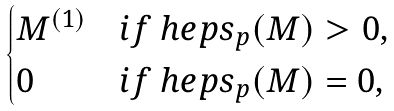Convert formula to latex. <formula><loc_0><loc_0><loc_500><loc_500>\begin{cases} { M } ^ { ( 1 ) } & i f \ h e p s _ { p } ( { M } ) > 0 , \\ 0 & i f \ h e p s _ { p } ( { M } ) = 0 , \end{cases}</formula> 